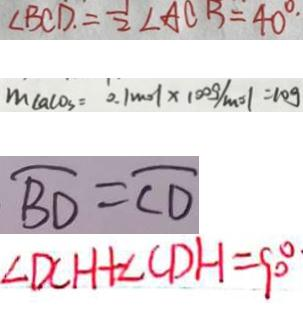<formula> <loc_0><loc_0><loc_500><loc_500>\angle B C D . = \frac { 1 } { 2 } \angle A C B = 4 0 ^ { \circ } . 
 m c a c o _ { 3 } = 0 . 1 m o l \times 1 0 0 g / m o l = 1 0 g 
 \widehat { B D } = \widehat { C D } 
 \angle D C H + \angle C D H = 9 0 ^ { \circ }</formula> 